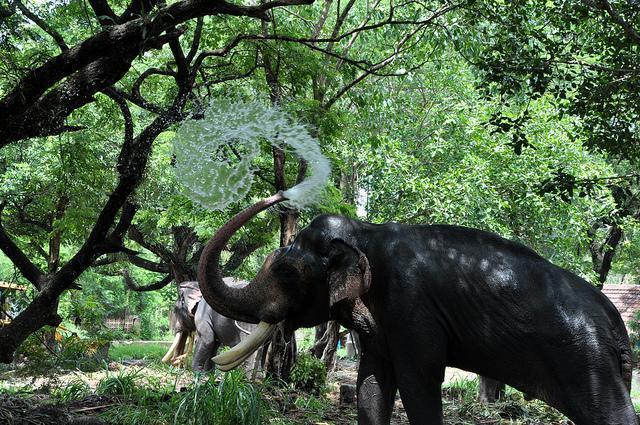How many elephants can you see?
Give a very brief answer. 2. How many elephants can be seen?
Give a very brief answer. 2. How many people are wearing brown shirt?
Give a very brief answer. 0. 